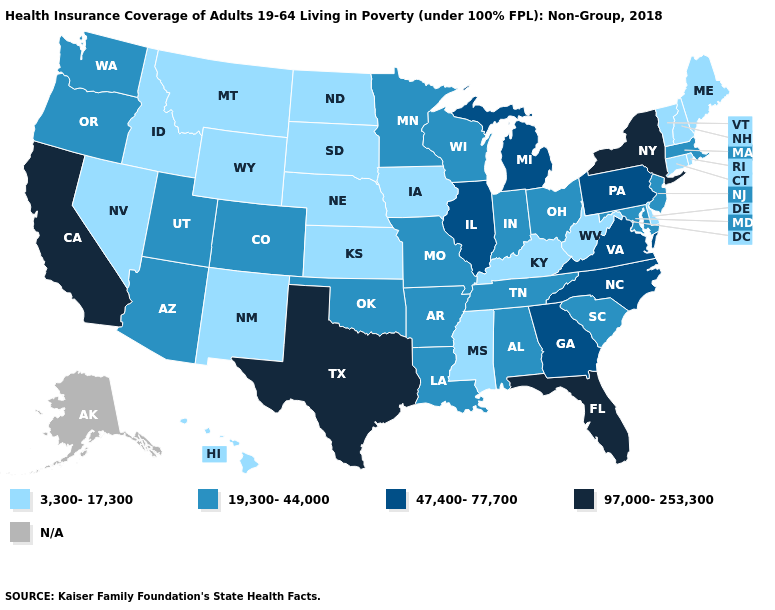Name the states that have a value in the range 97,000-253,300?
Concise answer only. California, Florida, New York, Texas. Does California have the highest value in the USA?
Short answer required. Yes. What is the value of New Jersey?
Give a very brief answer. 19,300-44,000. What is the value of Nebraska?
Give a very brief answer. 3,300-17,300. How many symbols are there in the legend?
Write a very short answer. 5. Does North Dakota have the lowest value in the MidWest?
Short answer required. Yes. Does the first symbol in the legend represent the smallest category?
Quick response, please. Yes. Does New York have the lowest value in the Northeast?
Keep it brief. No. What is the value of Texas?
Short answer required. 97,000-253,300. Does Colorado have the highest value in the USA?
Give a very brief answer. No. What is the lowest value in states that border Wisconsin?
Keep it brief. 3,300-17,300. What is the lowest value in the USA?
Keep it brief. 3,300-17,300. Name the states that have a value in the range N/A?
Write a very short answer. Alaska. Name the states that have a value in the range 19,300-44,000?
Write a very short answer. Alabama, Arizona, Arkansas, Colorado, Indiana, Louisiana, Maryland, Massachusetts, Minnesota, Missouri, New Jersey, Ohio, Oklahoma, Oregon, South Carolina, Tennessee, Utah, Washington, Wisconsin. Among the states that border Colorado , which have the highest value?
Write a very short answer. Arizona, Oklahoma, Utah. 